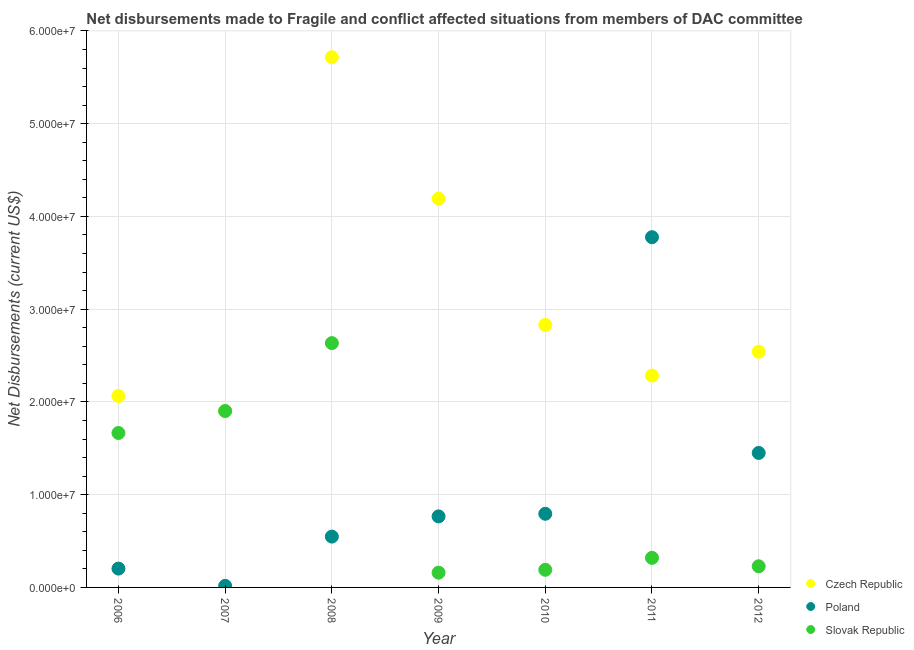What is the net disbursements made by slovak republic in 2009?
Your answer should be compact. 1.59e+06. Across all years, what is the maximum net disbursements made by slovak republic?
Your response must be concise. 2.63e+07. Across all years, what is the minimum net disbursements made by slovak republic?
Give a very brief answer. 1.59e+06. In which year was the net disbursements made by czech republic maximum?
Your answer should be compact. 2008. In which year was the net disbursements made by slovak republic minimum?
Make the answer very short. 2009. What is the total net disbursements made by czech republic in the graph?
Ensure brevity in your answer.  2.15e+08. What is the difference between the net disbursements made by slovak republic in 2008 and that in 2011?
Your answer should be compact. 2.32e+07. What is the difference between the net disbursements made by slovak republic in 2010 and the net disbursements made by czech republic in 2012?
Ensure brevity in your answer.  -2.35e+07. What is the average net disbursements made by czech republic per year?
Ensure brevity in your answer.  3.08e+07. In the year 2006, what is the difference between the net disbursements made by czech republic and net disbursements made by slovak republic?
Your response must be concise. 3.99e+06. What is the ratio of the net disbursements made by czech republic in 2008 to that in 2012?
Provide a short and direct response. 2.25. Is the net disbursements made by czech republic in 2009 less than that in 2012?
Provide a succinct answer. No. What is the difference between the highest and the second highest net disbursements made by slovak republic?
Give a very brief answer. 7.32e+06. What is the difference between the highest and the lowest net disbursements made by poland?
Give a very brief answer. 3.76e+07. Is the sum of the net disbursements made by poland in 2009 and 2012 greater than the maximum net disbursements made by czech republic across all years?
Make the answer very short. No. Is it the case that in every year, the sum of the net disbursements made by czech republic and net disbursements made by poland is greater than the net disbursements made by slovak republic?
Offer a very short reply. Yes. Is the net disbursements made by slovak republic strictly greater than the net disbursements made by poland over the years?
Provide a succinct answer. No. Is the net disbursements made by slovak republic strictly less than the net disbursements made by czech republic over the years?
Provide a short and direct response. No. How many years are there in the graph?
Provide a short and direct response. 7. What is the difference between two consecutive major ticks on the Y-axis?
Your response must be concise. 1.00e+07. Are the values on the major ticks of Y-axis written in scientific E-notation?
Ensure brevity in your answer.  Yes. Does the graph contain any zero values?
Provide a short and direct response. No. Does the graph contain grids?
Your response must be concise. Yes. How many legend labels are there?
Ensure brevity in your answer.  3. What is the title of the graph?
Offer a terse response. Net disbursements made to Fragile and conflict affected situations from members of DAC committee. Does "Czech Republic" appear as one of the legend labels in the graph?
Your response must be concise. Yes. What is the label or title of the X-axis?
Your answer should be very brief. Year. What is the label or title of the Y-axis?
Give a very brief answer. Net Disbursements (current US$). What is the Net Disbursements (current US$) of Czech Republic in 2006?
Your answer should be compact. 2.06e+07. What is the Net Disbursements (current US$) in Poland in 2006?
Your answer should be very brief. 2.03e+06. What is the Net Disbursements (current US$) in Slovak Republic in 2006?
Make the answer very short. 1.66e+07. What is the Net Disbursements (current US$) in Czech Republic in 2007?
Give a very brief answer. 1.90e+07. What is the Net Disbursements (current US$) in Slovak Republic in 2007?
Provide a succinct answer. 1.90e+07. What is the Net Disbursements (current US$) of Czech Republic in 2008?
Keep it short and to the point. 5.72e+07. What is the Net Disbursements (current US$) in Poland in 2008?
Offer a terse response. 5.48e+06. What is the Net Disbursements (current US$) in Slovak Republic in 2008?
Make the answer very short. 2.63e+07. What is the Net Disbursements (current US$) of Czech Republic in 2009?
Offer a very short reply. 4.19e+07. What is the Net Disbursements (current US$) in Poland in 2009?
Make the answer very short. 7.66e+06. What is the Net Disbursements (current US$) of Slovak Republic in 2009?
Your answer should be very brief. 1.59e+06. What is the Net Disbursements (current US$) in Czech Republic in 2010?
Give a very brief answer. 2.83e+07. What is the Net Disbursements (current US$) of Poland in 2010?
Provide a short and direct response. 7.94e+06. What is the Net Disbursements (current US$) of Slovak Republic in 2010?
Ensure brevity in your answer.  1.90e+06. What is the Net Disbursements (current US$) in Czech Republic in 2011?
Make the answer very short. 2.28e+07. What is the Net Disbursements (current US$) in Poland in 2011?
Provide a short and direct response. 3.78e+07. What is the Net Disbursements (current US$) of Slovak Republic in 2011?
Provide a succinct answer. 3.19e+06. What is the Net Disbursements (current US$) of Czech Republic in 2012?
Provide a short and direct response. 2.54e+07. What is the Net Disbursements (current US$) in Poland in 2012?
Provide a succinct answer. 1.45e+07. What is the Net Disbursements (current US$) of Slovak Republic in 2012?
Your answer should be compact. 2.28e+06. Across all years, what is the maximum Net Disbursements (current US$) in Czech Republic?
Offer a terse response. 5.72e+07. Across all years, what is the maximum Net Disbursements (current US$) in Poland?
Offer a very short reply. 3.78e+07. Across all years, what is the maximum Net Disbursements (current US$) of Slovak Republic?
Provide a short and direct response. 2.63e+07. Across all years, what is the minimum Net Disbursements (current US$) of Czech Republic?
Keep it short and to the point. 1.90e+07. Across all years, what is the minimum Net Disbursements (current US$) of Poland?
Ensure brevity in your answer.  1.70e+05. Across all years, what is the minimum Net Disbursements (current US$) in Slovak Republic?
Your answer should be very brief. 1.59e+06. What is the total Net Disbursements (current US$) in Czech Republic in the graph?
Your response must be concise. 2.15e+08. What is the total Net Disbursements (current US$) in Poland in the graph?
Offer a very short reply. 7.55e+07. What is the total Net Disbursements (current US$) in Slovak Republic in the graph?
Keep it short and to the point. 7.10e+07. What is the difference between the Net Disbursements (current US$) in Czech Republic in 2006 and that in 2007?
Your response must be concise. 1.64e+06. What is the difference between the Net Disbursements (current US$) in Poland in 2006 and that in 2007?
Make the answer very short. 1.86e+06. What is the difference between the Net Disbursements (current US$) of Slovak Republic in 2006 and that in 2007?
Give a very brief answer. -2.37e+06. What is the difference between the Net Disbursements (current US$) of Czech Republic in 2006 and that in 2008?
Your answer should be very brief. -3.65e+07. What is the difference between the Net Disbursements (current US$) of Poland in 2006 and that in 2008?
Give a very brief answer. -3.45e+06. What is the difference between the Net Disbursements (current US$) in Slovak Republic in 2006 and that in 2008?
Your answer should be very brief. -9.69e+06. What is the difference between the Net Disbursements (current US$) of Czech Republic in 2006 and that in 2009?
Provide a short and direct response. -2.13e+07. What is the difference between the Net Disbursements (current US$) of Poland in 2006 and that in 2009?
Ensure brevity in your answer.  -5.63e+06. What is the difference between the Net Disbursements (current US$) of Slovak Republic in 2006 and that in 2009?
Keep it short and to the point. 1.51e+07. What is the difference between the Net Disbursements (current US$) of Czech Republic in 2006 and that in 2010?
Provide a short and direct response. -7.66e+06. What is the difference between the Net Disbursements (current US$) in Poland in 2006 and that in 2010?
Offer a terse response. -5.91e+06. What is the difference between the Net Disbursements (current US$) in Slovak Republic in 2006 and that in 2010?
Make the answer very short. 1.48e+07. What is the difference between the Net Disbursements (current US$) of Czech Republic in 2006 and that in 2011?
Offer a very short reply. -2.20e+06. What is the difference between the Net Disbursements (current US$) of Poland in 2006 and that in 2011?
Provide a succinct answer. -3.57e+07. What is the difference between the Net Disbursements (current US$) in Slovak Republic in 2006 and that in 2011?
Offer a terse response. 1.35e+07. What is the difference between the Net Disbursements (current US$) in Czech Republic in 2006 and that in 2012?
Offer a very short reply. -4.77e+06. What is the difference between the Net Disbursements (current US$) of Poland in 2006 and that in 2012?
Provide a short and direct response. -1.25e+07. What is the difference between the Net Disbursements (current US$) in Slovak Republic in 2006 and that in 2012?
Your answer should be very brief. 1.44e+07. What is the difference between the Net Disbursements (current US$) in Czech Republic in 2007 and that in 2008?
Your answer should be compact. -3.82e+07. What is the difference between the Net Disbursements (current US$) in Poland in 2007 and that in 2008?
Your response must be concise. -5.31e+06. What is the difference between the Net Disbursements (current US$) in Slovak Republic in 2007 and that in 2008?
Offer a very short reply. -7.32e+06. What is the difference between the Net Disbursements (current US$) of Czech Republic in 2007 and that in 2009?
Your answer should be compact. -2.29e+07. What is the difference between the Net Disbursements (current US$) of Poland in 2007 and that in 2009?
Offer a terse response. -7.49e+06. What is the difference between the Net Disbursements (current US$) of Slovak Republic in 2007 and that in 2009?
Give a very brief answer. 1.74e+07. What is the difference between the Net Disbursements (current US$) of Czech Republic in 2007 and that in 2010?
Keep it short and to the point. -9.30e+06. What is the difference between the Net Disbursements (current US$) of Poland in 2007 and that in 2010?
Your response must be concise. -7.77e+06. What is the difference between the Net Disbursements (current US$) in Slovak Republic in 2007 and that in 2010?
Offer a very short reply. 1.71e+07. What is the difference between the Net Disbursements (current US$) of Czech Republic in 2007 and that in 2011?
Give a very brief answer. -3.84e+06. What is the difference between the Net Disbursements (current US$) in Poland in 2007 and that in 2011?
Provide a short and direct response. -3.76e+07. What is the difference between the Net Disbursements (current US$) of Slovak Republic in 2007 and that in 2011?
Keep it short and to the point. 1.58e+07. What is the difference between the Net Disbursements (current US$) in Czech Republic in 2007 and that in 2012?
Keep it short and to the point. -6.41e+06. What is the difference between the Net Disbursements (current US$) in Poland in 2007 and that in 2012?
Your answer should be very brief. -1.43e+07. What is the difference between the Net Disbursements (current US$) of Slovak Republic in 2007 and that in 2012?
Offer a very short reply. 1.67e+07. What is the difference between the Net Disbursements (current US$) of Czech Republic in 2008 and that in 2009?
Ensure brevity in your answer.  1.52e+07. What is the difference between the Net Disbursements (current US$) of Poland in 2008 and that in 2009?
Your answer should be compact. -2.18e+06. What is the difference between the Net Disbursements (current US$) of Slovak Republic in 2008 and that in 2009?
Give a very brief answer. 2.48e+07. What is the difference between the Net Disbursements (current US$) of Czech Republic in 2008 and that in 2010?
Offer a terse response. 2.89e+07. What is the difference between the Net Disbursements (current US$) in Poland in 2008 and that in 2010?
Provide a short and direct response. -2.46e+06. What is the difference between the Net Disbursements (current US$) of Slovak Republic in 2008 and that in 2010?
Provide a succinct answer. 2.44e+07. What is the difference between the Net Disbursements (current US$) in Czech Republic in 2008 and that in 2011?
Give a very brief answer. 3.43e+07. What is the difference between the Net Disbursements (current US$) of Poland in 2008 and that in 2011?
Offer a very short reply. -3.23e+07. What is the difference between the Net Disbursements (current US$) in Slovak Republic in 2008 and that in 2011?
Your answer should be compact. 2.32e+07. What is the difference between the Net Disbursements (current US$) of Czech Republic in 2008 and that in 2012?
Keep it short and to the point. 3.18e+07. What is the difference between the Net Disbursements (current US$) of Poland in 2008 and that in 2012?
Offer a very short reply. -9.02e+06. What is the difference between the Net Disbursements (current US$) in Slovak Republic in 2008 and that in 2012?
Your answer should be compact. 2.41e+07. What is the difference between the Net Disbursements (current US$) in Czech Republic in 2009 and that in 2010?
Keep it short and to the point. 1.36e+07. What is the difference between the Net Disbursements (current US$) in Poland in 2009 and that in 2010?
Your answer should be compact. -2.80e+05. What is the difference between the Net Disbursements (current US$) in Slovak Republic in 2009 and that in 2010?
Ensure brevity in your answer.  -3.10e+05. What is the difference between the Net Disbursements (current US$) of Czech Republic in 2009 and that in 2011?
Your answer should be compact. 1.91e+07. What is the difference between the Net Disbursements (current US$) of Poland in 2009 and that in 2011?
Give a very brief answer. -3.01e+07. What is the difference between the Net Disbursements (current US$) of Slovak Republic in 2009 and that in 2011?
Give a very brief answer. -1.60e+06. What is the difference between the Net Disbursements (current US$) of Czech Republic in 2009 and that in 2012?
Provide a succinct answer. 1.65e+07. What is the difference between the Net Disbursements (current US$) in Poland in 2009 and that in 2012?
Your answer should be compact. -6.84e+06. What is the difference between the Net Disbursements (current US$) of Slovak Republic in 2009 and that in 2012?
Your answer should be very brief. -6.90e+05. What is the difference between the Net Disbursements (current US$) in Czech Republic in 2010 and that in 2011?
Your answer should be very brief. 5.46e+06. What is the difference between the Net Disbursements (current US$) of Poland in 2010 and that in 2011?
Make the answer very short. -2.98e+07. What is the difference between the Net Disbursements (current US$) of Slovak Republic in 2010 and that in 2011?
Your response must be concise. -1.29e+06. What is the difference between the Net Disbursements (current US$) of Czech Republic in 2010 and that in 2012?
Your response must be concise. 2.89e+06. What is the difference between the Net Disbursements (current US$) of Poland in 2010 and that in 2012?
Your answer should be very brief. -6.56e+06. What is the difference between the Net Disbursements (current US$) in Slovak Republic in 2010 and that in 2012?
Offer a terse response. -3.80e+05. What is the difference between the Net Disbursements (current US$) of Czech Republic in 2011 and that in 2012?
Your answer should be compact. -2.57e+06. What is the difference between the Net Disbursements (current US$) of Poland in 2011 and that in 2012?
Your answer should be very brief. 2.33e+07. What is the difference between the Net Disbursements (current US$) of Slovak Republic in 2011 and that in 2012?
Your response must be concise. 9.10e+05. What is the difference between the Net Disbursements (current US$) of Czech Republic in 2006 and the Net Disbursements (current US$) of Poland in 2007?
Make the answer very short. 2.05e+07. What is the difference between the Net Disbursements (current US$) in Czech Republic in 2006 and the Net Disbursements (current US$) in Slovak Republic in 2007?
Your answer should be compact. 1.62e+06. What is the difference between the Net Disbursements (current US$) in Poland in 2006 and the Net Disbursements (current US$) in Slovak Republic in 2007?
Your response must be concise. -1.70e+07. What is the difference between the Net Disbursements (current US$) of Czech Republic in 2006 and the Net Disbursements (current US$) of Poland in 2008?
Offer a terse response. 1.52e+07. What is the difference between the Net Disbursements (current US$) in Czech Republic in 2006 and the Net Disbursements (current US$) in Slovak Republic in 2008?
Your answer should be compact. -5.70e+06. What is the difference between the Net Disbursements (current US$) of Poland in 2006 and the Net Disbursements (current US$) of Slovak Republic in 2008?
Provide a short and direct response. -2.43e+07. What is the difference between the Net Disbursements (current US$) in Czech Republic in 2006 and the Net Disbursements (current US$) in Poland in 2009?
Your response must be concise. 1.30e+07. What is the difference between the Net Disbursements (current US$) of Czech Republic in 2006 and the Net Disbursements (current US$) of Slovak Republic in 2009?
Keep it short and to the point. 1.90e+07. What is the difference between the Net Disbursements (current US$) in Czech Republic in 2006 and the Net Disbursements (current US$) in Poland in 2010?
Offer a terse response. 1.27e+07. What is the difference between the Net Disbursements (current US$) in Czech Republic in 2006 and the Net Disbursements (current US$) in Slovak Republic in 2010?
Ensure brevity in your answer.  1.87e+07. What is the difference between the Net Disbursements (current US$) in Poland in 2006 and the Net Disbursements (current US$) in Slovak Republic in 2010?
Your response must be concise. 1.30e+05. What is the difference between the Net Disbursements (current US$) of Czech Republic in 2006 and the Net Disbursements (current US$) of Poland in 2011?
Offer a very short reply. -1.71e+07. What is the difference between the Net Disbursements (current US$) of Czech Republic in 2006 and the Net Disbursements (current US$) of Slovak Republic in 2011?
Keep it short and to the point. 1.74e+07. What is the difference between the Net Disbursements (current US$) in Poland in 2006 and the Net Disbursements (current US$) in Slovak Republic in 2011?
Your answer should be very brief. -1.16e+06. What is the difference between the Net Disbursements (current US$) in Czech Republic in 2006 and the Net Disbursements (current US$) in Poland in 2012?
Your answer should be compact. 6.14e+06. What is the difference between the Net Disbursements (current US$) of Czech Republic in 2006 and the Net Disbursements (current US$) of Slovak Republic in 2012?
Ensure brevity in your answer.  1.84e+07. What is the difference between the Net Disbursements (current US$) of Poland in 2006 and the Net Disbursements (current US$) of Slovak Republic in 2012?
Your answer should be very brief. -2.50e+05. What is the difference between the Net Disbursements (current US$) in Czech Republic in 2007 and the Net Disbursements (current US$) in Poland in 2008?
Offer a very short reply. 1.35e+07. What is the difference between the Net Disbursements (current US$) in Czech Republic in 2007 and the Net Disbursements (current US$) in Slovak Republic in 2008?
Provide a succinct answer. -7.34e+06. What is the difference between the Net Disbursements (current US$) in Poland in 2007 and the Net Disbursements (current US$) in Slovak Republic in 2008?
Ensure brevity in your answer.  -2.62e+07. What is the difference between the Net Disbursements (current US$) of Czech Republic in 2007 and the Net Disbursements (current US$) of Poland in 2009?
Provide a succinct answer. 1.13e+07. What is the difference between the Net Disbursements (current US$) of Czech Republic in 2007 and the Net Disbursements (current US$) of Slovak Republic in 2009?
Your answer should be very brief. 1.74e+07. What is the difference between the Net Disbursements (current US$) of Poland in 2007 and the Net Disbursements (current US$) of Slovak Republic in 2009?
Your response must be concise. -1.42e+06. What is the difference between the Net Disbursements (current US$) in Czech Republic in 2007 and the Net Disbursements (current US$) in Poland in 2010?
Offer a very short reply. 1.11e+07. What is the difference between the Net Disbursements (current US$) of Czech Republic in 2007 and the Net Disbursements (current US$) of Slovak Republic in 2010?
Your response must be concise. 1.71e+07. What is the difference between the Net Disbursements (current US$) of Poland in 2007 and the Net Disbursements (current US$) of Slovak Republic in 2010?
Your answer should be very brief. -1.73e+06. What is the difference between the Net Disbursements (current US$) in Czech Republic in 2007 and the Net Disbursements (current US$) in Poland in 2011?
Your response must be concise. -1.88e+07. What is the difference between the Net Disbursements (current US$) of Czech Republic in 2007 and the Net Disbursements (current US$) of Slovak Republic in 2011?
Provide a short and direct response. 1.58e+07. What is the difference between the Net Disbursements (current US$) of Poland in 2007 and the Net Disbursements (current US$) of Slovak Republic in 2011?
Your response must be concise. -3.02e+06. What is the difference between the Net Disbursements (current US$) in Czech Republic in 2007 and the Net Disbursements (current US$) in Poland in 2012?
Give a very brief answer. 4.50e+06. What is the difference between the Net Disbursements (current US$) of Czech Republic in 2007 and the Net Disbursements (current US$) of Slovak Republic in 2012?
Ensure brevity in your answer.  1.67e+07. What is the difference between the Net Disbursements (current US$) in Poland in 2007 and the Net Disbursements (current US$) in Slovak Republic in 2012?
Ensure brevity in your answer.  -2.11e+06. What is the difference between the Net Disbursements (current US$) of Czech Republic in 2008 and the Net Disbursements (current US$) of Poland in 2009?
Ensure brevity in your answer.  4.95e+07. What is the difference between the Net Disbursements (current US$) of Czech Republic in 2008 and the Net Disbursements (current US$) of Slovak Republic in 2009?
Offer a very short reply. 5.56e+07. What is the difference between the Net Disbursements (current US$) in Poland in 2008 and the Net Disbursements (current US$) in Slovak Republic in 2009?
Offer a very short reply. 3.89e+06. What is the difference between the Net Disbursements (current US$) in Czech Republic in 2008 and the Net Disbursements (current US$) in Poland in 2010?
Offer a terse response. 4.92e+07. What is the difference between the Net Disbursements (current US$) of Czech Republic in 2008 and the Net Disbursements (current US$) of Slovak Republic in 2010?
Provide a short and direct response. 5.53e+07. What is the difference between the Net Disbursements (current US$) in Poland in 2008 and the Net Disbursements (current US$) in Slovak Republic in 2010?
Ensure brevity in your answer.  3.58e+06. What is the difference between the Net Disbursements (current US$) in Czech Republic in 2008 and the Net Disbursements (current US$) in Poland in 2011?
Make the answer very short. 1.94e+07. What is the difference between the Net Disbursements (current US$) in Czech Republic in 2008 and the Net Disbursements (current US$) in Slovak Republic in 2011?
Your response must be concise. 5.40e+07. What is the difference between the Net Disbursements (current US$) in Poland in 2008 and the Net Disbursements (current US$) in Slovak Republic in 2011?
Ensure brevity in your answer.  2.29e+06. What is the difference between the Net Disbursements (current US$) in Czech Republic in 2008 and the Net Disbursements (current US$) in Poland in 2012?
Offer a very short reply. 4.27e+07. What is the difference between the Net Disbursements (current US$) of Czech Republic in 2008 and the Net Disbursements (current US$) of Slovak Republic in 2012?
Give a very brief answer. 5.49e+07. What is the difference between the Net Disbursements (current US$) in Poland in 2008 and the Net Disbursements (current US$) in Slovak Republic in 2012?
Provide a succinct answer. 3.20e+06. What is the difference between the Net Disbursements (current US$) in Czech Republic in 2009 and the Net Disbursements (current US$) in Poland in 2010?
Your answer should be very brief. 3.40e+07. What is the difference between the Net Disbursements (current US$) in Czech Republic in 2009 and the Net Disbursements (current US$) in Slovak Republic in 2010?
Give a very brief answer. 4.00e+07. What is the difference between the Net Disbursements (current US$) of Poland in 2009 and the Net Disbursements (current US$) of Slovak Republic in 2010?
Your response must be concise. 5.76e+06. What is the difference between the Net Disbursements (current US$) of Czech Republic in 2009 and the Net Disbursements (current US$) of Poland in 2011?
Your answer should be very brief. 4.15e+06. What is the difference between the Net Disbursements (current US$) in Czech Republic in 2009 and the Net Disbursements (current US$) in Slovak Republic in 2011?
Provide a succinct answer. 3.87e+07. What is the difference between the Net Disbursements (current US$) in Poland in 2009 and the Net Disbursements (current US$) in Slovak Republic in 2011?
Your answer should be very brief. 4.47e+06. What is the difference between the Net Disbursements (current US$) of Czech Republic in 2009 and the Net Disbursements (current US$) of Poland in 2012?
Provide a succinct answer. 2.74e+07. What is the difference between the Net Disbursements (current US$) of Czech Republic in 2009 and the Net Disbursements (current US$) of Slovak Republic in 2012?
Provide a short and direct response. 3.96e+07. What is the difference between the Net Disbursements (current US$) of Poland in 2009 and the Net Disbursements (current US$) of Slovak Republic in 2012?
Give a very brief answer. 5.38e+06. What is the difference between the Net Disbursements (current US$) in Czech Republic in 2010 and the Net Disbursements (current US$) in Poland in 2011?
Provide a succinct answer. -9.46e+06. What is the difference between the Net Disbursements (current US$) of Czech Republic in 2010 and the Net Disbursements (current US$) of Slovak Republic in 2011?
Your answer should be compact. 2.51e+07. What is the difference between the Net Disbursements (current US$) of Poland in 2010 and the Net Disbursements (current US$) of Slovak Republic in 2011?
Keep it short and to the point. 4.75e+06. What is the difference between the Net Disbursements (current US$) in Czech Republic in 2010 and the Net Disbursements (current US$) in Poland in 2012?
Offer a terse response. 1.38e+07. What is the difference between the Net Disbursements (current US$) of Czech Republic in 2010 and the Net Disbursements (current US$) of Slovak Republic in 2012?
Ensure brevity in your answer.  2.60e+07. What is the difference between the Net Disbursements (current US$) in Poland in 2010 and the Net Disbursements (current US$) in Slovak Republic in 2012?
Offer a very short reply. 5.66e+06. What is the difference between the Net Disbursements (current US$) in Czech Republic in 2011 and the Net Disbursements (current US$) in Poland in 2012?
Keep it short and to the point. 8.34e+06. What is the difference between the Net Disbursements (current US$) of Czech Republic in 2011 and the Net Disbursements (current US$) of Slovak Republic in 2012?
Your answer should be very brief. 2.06e+07. What is the difference between the Net Disbursements (current US$) in Poland in 2011 and the Net Disbursements (current US$) in Slovak Republic in 2012?
Provide a short and direct response. 3.55e+07. What is the average Net Disbursements (current US$) in Czech Republic per year?
Ensure brevity in your answer.  3.08e+07. What is the average Net Disbursements (current US$) in Poland per year?
Your answer should be very brief. 1.08e+07. What is the average Net Disbursements (current US$) in Slovak Republic per year?
Your response must be concise. 1.01e+07. In the year 2006, what is the difference between the Net Disbursements (current US$) of Czech Republic and Net Disbursements (current US$) of Poland?
Make the answer very short. 1.86e+07. In the year 2006, what is the difference between the Net Disbursements (current US$) in Czech Republic and Net Disbursements (current US$) in Slovak Republic?
Your answer should be very brief. 3.99e+06. In the year 2006, what is the difference between the Net Disbursements (current US$) of Poland and Net Disbursements (current US$) of Slovak Republic?
Make the answer very short. -1.46e+07. In the year 2007, what is the difference between the Net Disbursements (current US$) in Czech Republic and Net Disbursements (current US$) in Poland?
Provide a short and direct response. 1.88e+07. In the year 2007, what is the difference between the Net Disbursements (current US$) of Poland and Net Disbursements (current US$) of Slovak Republic?
Your response must be concise. -1.88e+07. In the year 2008, what is the difference between the Net Disbursements (current US$) of Czech Republic and Net Disbursements (current US$) of Poland?
Make the answer very short. 5.17e+07. In the year 2008, what is the difference between the Net Disbursements (current US$) of Czech Republic and Net Disbursements (current US$) of Slovak Republic?
Offer a terse response. 3.08e+07. In the year 2008, what is the difference between the Net Disbursements (current US$) of Poland and Net Disbursements (current US$) of Slovak Republic?
Provide a short and direct response. -2.09e+07. In the year 2009, what is the difference between the Net Disbursements (current US$) of Czech Republic and Net Disbursements (current US$) of Poland?
Provide a short and direct response. 3.42e+07. In the year 2009, what is the difference between the Net Disbursements (current US$) of Czech Republic and Net Disbursements (current US$) of Slovak Republic?
Your answer should be very brief. 4.03e+07. In the year 2009, what is the difference between the Net Disbursements (current US$) of Poland and Net Disbursements (current US$) of Slovak Republic?
Give a very brief answer. 6.07e+06. In the year 2010, what is the difference between the Net Disbursements (current US$) in Czech Republic and Net Disbursements (current US$) in Poland?
Offer a terse response. 2.04e+07. In the year 2010, what is the difference between the Net Disbursements (current US$) in Czech Republic and Net Disbursements (current US$) in Slovak Republic?
Provide a short and direct response. 2.64e+07. In the year 2010, what is the difference between the Net Disbursements (current US$) of Poland and Net Disbursements (current US$) of Slovak Republic?
Give a very brief answer. 6.04e+06. In the year 2011, what is the difference between the Net Disbursements (current US$) in Czech Republic and Net Disbursements (current US$) in Poland?
Keep it short and to the point. -1.49e+07. In the year 2011, what is the difference between the Net Disbursements (current US$) in Czech Republic and Net Disbursements (current US$) in Slovak Republic?
Make the answer very short. 1.96e+07. In the year 2011, what is the difference between the Net Disbursements (current US$) in Poland and Net Disbursements (current US$) in Slovak Republic?
Your response must be concise. 3.46e+07. In the year 2012, what is the difference between the Net Disbursements (current US$) in Czech Republic and Net Disbursements (current US$) in Poland?
Ensure brevity in your answer.  1.09e+07. In the year 2012, what is the difference between the Net Disbursements (current US$) of Czech Republic and Net Disbursements (current US$) of Slovak Republic?
Keep it short and to the point. 2.31e+07. In the year 2012, what is the difference between the Net Disbursements (current US$) of Poland and Net Disbursements (current US$) of Slovak Republic?
Keep it short and to the point. 1.22e+07. What is the ratio of the Net Disbursements (current US$) in Czech Republic in 2006 to that in 2007?
Offer a terse response. 1.09. What is the ratio of the Net Disbursements (current US$) in Poland in 2006 to that in 2007?
Offer a very short reply. 11.94. What is the ratio of the Net Disbursements (current US$) in Slovak Republic in 2006 to that in 2007?
Make the answer very short. 0.88. What is the ratio of the Net Disbursements (current US$) in Czech Republic in 2006 to that in 2008?
Your response must be concise. 0.36. What is the ratio of the Net Disbursements (current US$) in Poland in 2006 to that in 2008?
Offer a terse response. 0.37. What is the ratio of the Net Disbursements (current US$) in Slovak Republic in 2006 to that in 2008?
Give a very brief answer. 0.63. What is the ratio of the Net Disbursements (current US$) in Czech Republic in 2006 to that in 2009?
Provide a short and direct response. 0.49. What is the ratio of the Net Disbursements (current US$) of Poland in 2006 to that in 2009?
Give a very brief answer. 0.27. What is the ratio of the Net Disbursements (current US$) in Slovak Republic in 2006 to that in 2009?
Your response must be concise. 10.47. What is the ratio of the Net Disbursements (current US$) of Czech Republic in 2006 to that in 2010?
Your answer should be compact. 0.73. What is the ratio of the Net Disbursements (current US$) of Poland in 2006 to that in 2010?
Ensure brevity in your answer.  0.26. What is the ratio of the Net Disbursements (current US$) in Slovak Republic in 2006 to that in 2010?
Offer a very short reply. 8.76. What is the ratio of the Net Disbursements (current US$) in Czech Republic in 2006 to that in 2011?
Ensure brevity in your answer.  0.9. What is the ratio of the Net Disbursements (current US$) of Poland in 2006 to that in 2011?
Give a very brief answer. 0.05. What is the ratio of the Net Disbursements (current US$) of Slovak Republic in 2006 to that in 2011?
Provide a short and direct response. 5.22. What is the ratio of the Net Disbursements (current US$) in Czech Republic in 2006 to that in 2012?
Your answer should be compact. 0.81. What is the ratio of the Net Disbursements (current US$) of Poland in 2006 to that in 2012?
Provide a succinct answer. 0.14. What is the ratio of the Net Disbursements (current US$) in Slovak Republic in 2006 to that in 2012?
Your answer should be compact. 7.3. What is the ratio of the Net Disbursements (current US$) in Czech Republic in 2007 to that in 2008?
Your answer should be compact. 0.33. What is the ratio of the Net Disbursements (current US$) in Poland in 2007 to that in 2008?
Ensure brevity in your answer.  0.03. What is the ratio of the Net Disbursements (current US$) in Slovak Republic in 2007 to that in 2008?
Your answer should be compact. 0.72. What is the ratio of the Net Disbursements (current US$) in Czech Republic in 2007 to that in 2009?
Make the answer very short. 0.45. What is the ratio of the Net Disbursements (current US$) in Poland in 2007 to that in 2009?
Offer a terse response. 0.02. What is the ratio of the Net Disbursements (current US$) in Slovak Republic in 2007 to that in 2009?
Provide a short and direct response. 11.96. What is the ratio of the Net Disbursements (current US$) of Czech Republic in 2007 to that in 2010?
Ensure brevity in your answer.  0.67. What is the ratio of the Net Disbursements (current US$) of Poland in 2007 to that in 2010?
Provide a short and direct response. 0.02. What is the ratio of the Net Disbursements (current US$) of Slovak Republic in 2007 to that in 2010?
Provide a succinct answer. 10.01. What is the ratio of the Net Disbursements (current US$) of Czech Republic in 2007 to that in 2011?
Provide a short and direct response. 0.83. What is the ratio of the Net Disbursements (current US$) in Poland in 2007 to that in 2011?
Ensure brevity in your answer.  0. What is the ratio of the Net Disbursements (current US$) in Slovak Republic in 2007 to that in 2011?
Your answer should be compact. 5.96. What is the ratio of the Net Disbursements (current US$) of Czech Republic in 2007 to that in 2012?
Give a very brief answer. 0.75. What is the ratio of the Net Disbursements (current US$) in Poland in 2007 to that in 2012?
Your answer should be compact. 0.01. What is the ratio of the Net Disbursements (current US$) in Slovak Republic in 2007 to that in 2012?
Make the answer very short. 8.34. What is the ratio of the Net Disbursements (current US$) of Czech Republic in 2008 to that in 2009?
Offer a very short reply. 1.36. What is the ratio of the Net Disbursements (current US$) of Poland in 2008 to that in 2009?
Provide a succinct answer. 0.72. What is the ratio of the Net Disbursements (current US$) in Slovak Republic in 2008 to that in 2009?
Provide a short and direct response. 16.57. What is the ratio of the Net Disbursements (current US$) in Czech Republic in 2008 to that in 2010?
Provide a succinct answer. 2.02. What is the ratio of the Net Disbursements (current US$) in Poland in 2008 to that in 2010?
Provide a short and direct response. 0.69. What is the ratio of the Net Disbursements (current US$) in Slovak Republic in 2008 to that in 2010?
Ensure brevity in your answer.  13.86. What is the ratio of the Net Disbursements (current US$) in Czech Republic in 2008 to that in 2011?
Give a very brief answer. 2.5. What is the ratio of the Net Disbursements (current US$) in Poland in 2008 to that in 2011?
Offer a very short reply. 0.15. What is the ratio of the Net Disbursements (current US$) in Slovak Republic in 2008 to that in 2011?
Offer a very short reply. 8.26. What is the ratio of the Net Disbursements (current US$) of Czech Republic in 2008 to that in 2012?
Make the answer very short. 2.25. What is the ratio of the Net Disbursements (current US$) of Poland in 2008 to that in 2012?
Make the answer very short. 0.38. What is the ratio of the Net Disbursements (current US$) of Slovak Republic in 2008 to that in 2012?
Your answer should be very brief. 11.55. What is the ratio of the Net Disbursements (current US$) in Czech Republic in 2009 to that in 2010?
Your answer should be very brief. 1.48. What is the ratio of the Net Disbursements (current US$) in Poland in 2009 to that in 2010?
Your response must be concise. 0.96. What is the ratio of the Net Disbursements (current US$) of Slovak Republic in 2009 to that in 2010?
Ensure brevity in your answer.  0.84. What is the ratio of the Net Disbursements (current US$) in Czech Republic in 2009 to that in 2011?
Provide a short and direct response. 1.83. What is the ratio of the Net Disbursements (current US$) of Poland in 2009 to that in 2011?
Your response must be concise. 0.2. What is the ratio of the Net Disbursements (current US$) of Slovak Republic in 2009 to that in 2011?
Make the answer very short. 0.5. What is the ratio of the Net Disbursements (current US$) in Czech Republic in 2009 to that in 2012?
Offer a very short reply. 1.65. What is the ratio of the Net Disbursements (current US$) in Poland in 2009 to that in 2012?
Keep it short and to the point. 0.53. What is the ratio of the Net Disbursements (current US$) of Slovak Republic in 2009 to that in 2012?
Keep it short and to the point. 0.7. What is the ratio of the Net Disbursements (current US$) of Czech Republic in 2010 to that in 2011?
Your response must be concise. 1.24. What is the ratio of the Net Disbursements (current US$) in Poland in 2010 to that in 2011?
Keep it short and to the point. 0.21. What is the ratio of the Net Disbursements (current US$) of Slovak Republic in 2010 to that in 2011?
Give a very brief answer. 0.6. What is the ratio of the Net Disbursements (current US$) in Czech Republic in 2010 to that in 2012?
Give a very brief answer. 1.11. What is the ratio of the Net Disbursements (current US$) in Poland in 2010 to that in 2012?
Give a very brief answer. 0.55. What is the ratio of the Net Disbursements (current US$) of Slovak Republic in 2010 to that in 2012?
Your answer should be very brief. 0.83. What is the ratio of the Net Disbursements (current US$) of Czech Republic in 2011 to that in 2012?
Make the answer very short. 0.9. What is the ratio of the Net Disbursements (current US$) in Poland in 2011 to that in 2012?
Your answer should be compact. 2.6. What is the ratio of the Net Disbursements (current US$) in Slovak Republic in 2011 to that in 2012?
Your response must be concise. 1.4. What is the difference between the highest and the second highest Net Disbursements (current US$) in Czech Republic?
Offer a terse response. 1.52e+07. What is the difference between the highest and the second highest Net Disbursements (current US$) of Poland?
Your response must be concise. 2.33e+07. What is the difference between the highest and the second highest Net Disbursements (current US$) of Slovak Republic?
Offer a terse response. 7.32e+06. What is the difference between the highest and the lowest Net Disbursements (current US$) in Czech Republic?
Keep it short and to the point. 3.82e+07. What is the difference between the highest and the lowest Net Disbursements (current US$) in Poland?
Your response must be concise. 3.76e+07. What is the difference between the highest and the lowest Net Disbursements (current US$) of Slovak Republic?
Offer a terse response. 2.48e+07. 